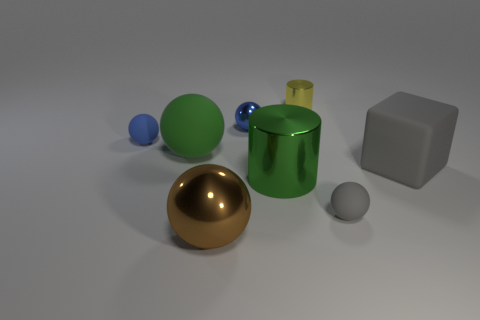There is a tiny blue object left of the large brown shiny thing; how many large green matte spheres are in front of it?
Provide a succinct answer. 1. There is a big object behind the big gray rubber cube; does it have the same color as the large matte block?
Provide a succinct answer. No. What number of objects are green metal things or big rubber balls that are on the right side of the tiny blue matte thing?
Provide a succinct answer. 2. There is a tiny metallic thing that is on the left side of the large green metallic cylinder; is it the same shape as the green thing behind the big gray rubber object?
Provide a short and direct response. Yes. Is there anything else that has the same color as the matte block?
Offer a very short reply. Yes. There is a tiny blue object that is the same material as the large green sphere; what shape is it?
Give a very brief answer. Sphere. What is the material of the tiny object that is both right of the green cylinder and behind the big rubber ball?
Your answer should be compact. Metal. Is the color of the large rubber block the same as the large matte sphere?
Ensure brevity in your answer.  No. There is a matte thing that is the same color as the rubber block; what is its shape?
Give a very brief answer. Sphere. How many other tiny things are the same shape as the tiny gray matte object?
Give a very brief answer. 2. 